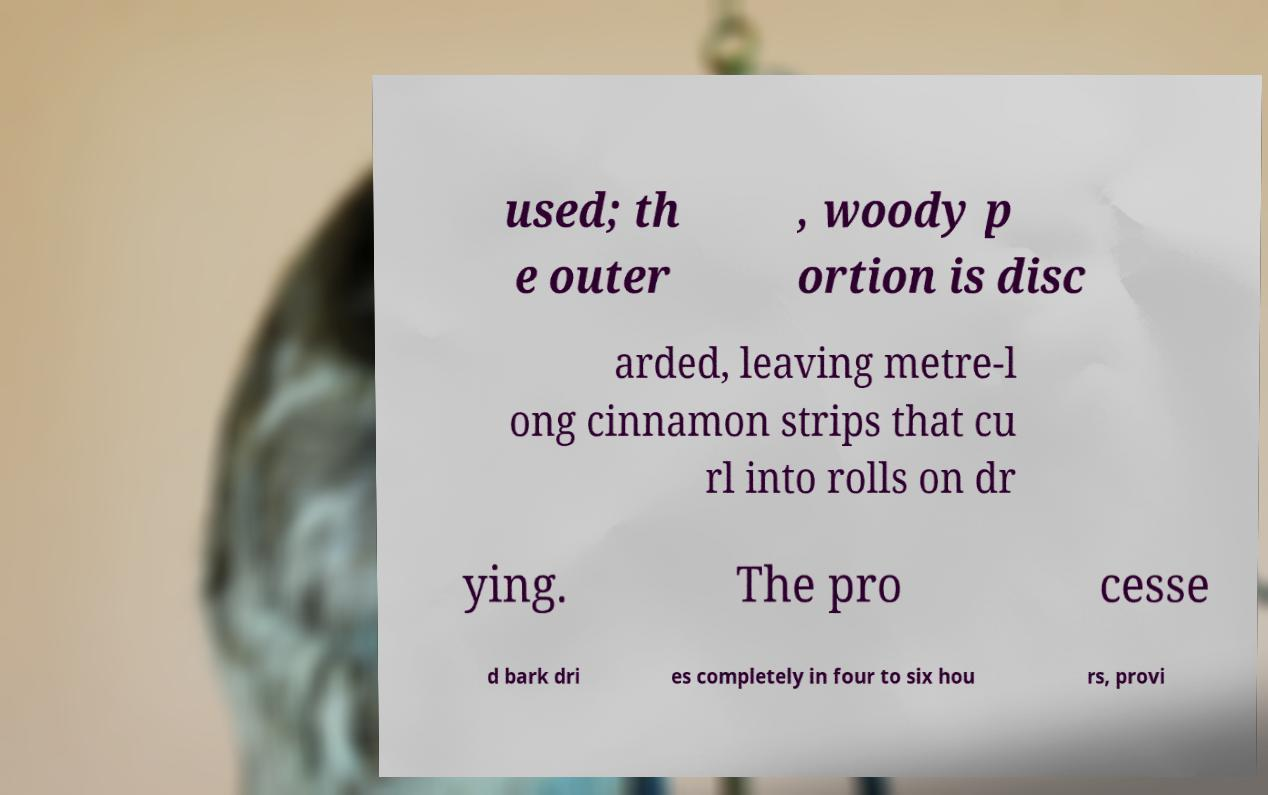Please read and relay the text visible in this image. What does it say? used; th e outer , woody p ortion is disc arded, leaving metre-l ong cinnamon strips that cu rl into rolls on dr ying. The pro cesse d bark dri es completely in four to six hou rs, provi 